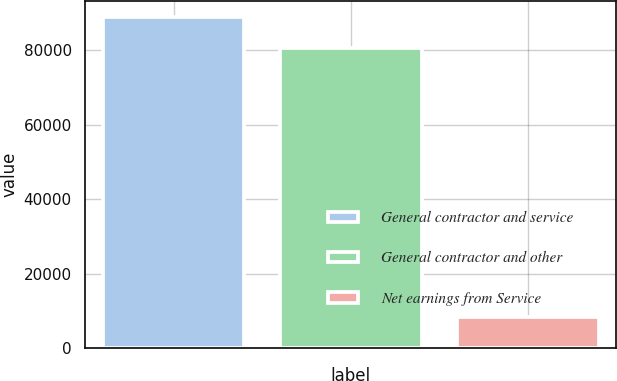Convert chart to OTSL. <chart><loc_0><loc_0><loc_500><loc_500><bar_chart><fcel>General contractor and service<fcel>General contractor and other<fcel>Net earnings from Service<nl><fcel>88810<fcel>80467<fcel>8343<nl></chart> 